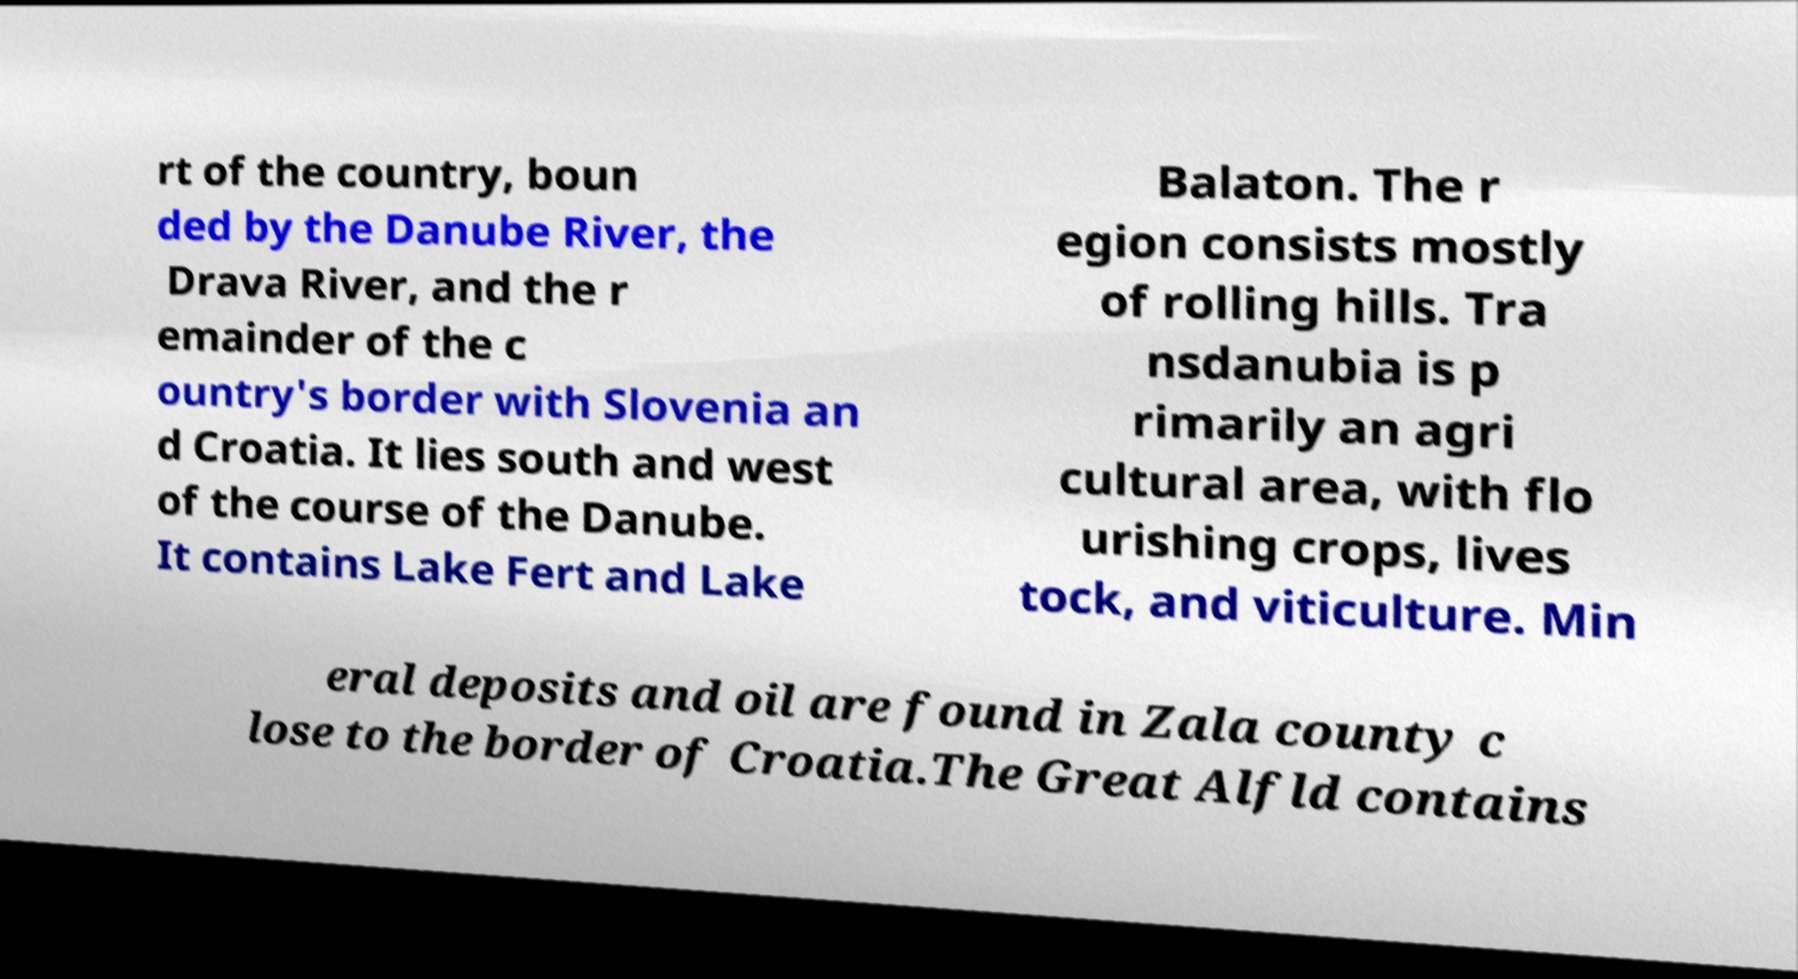Could you assist in decoding the text presented in this image and type it out clearly? rt of the country, boun ded by the Danube River, the Drava River, and the r emainder of the c ountry's border with Slovenia an d Croatia. It lies south and west of the course of the Danube. It contains Lake Fert and Lake Balaton. The r egion consists mostly of rolling hills. Tra nsdanubia is p rimarily an agri cultural area, with flo urishing crops, lives tock, and viticulture. Min eral deposits and oil are found in Zala county c lose to the border of Croatia.The Great Alfld contains 